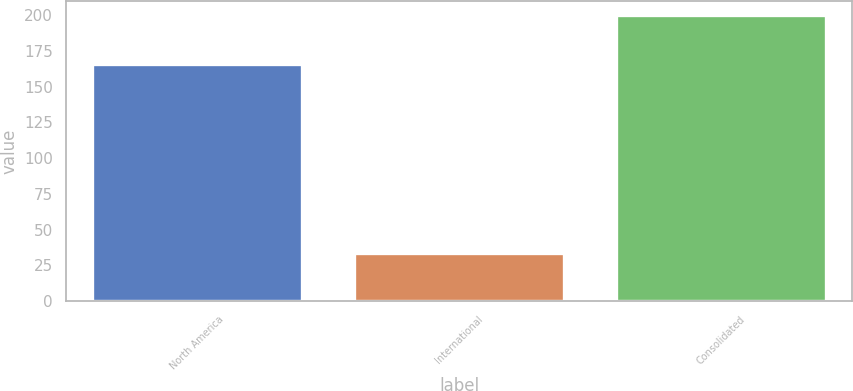<chart> <loc_0><loc_0><loc_500><loc_500><bar_chart><fcel>North America<fcel>International<fcel>Consolidated<nl><fcel>166<fcel>34<fcel>200<nl></chart> 